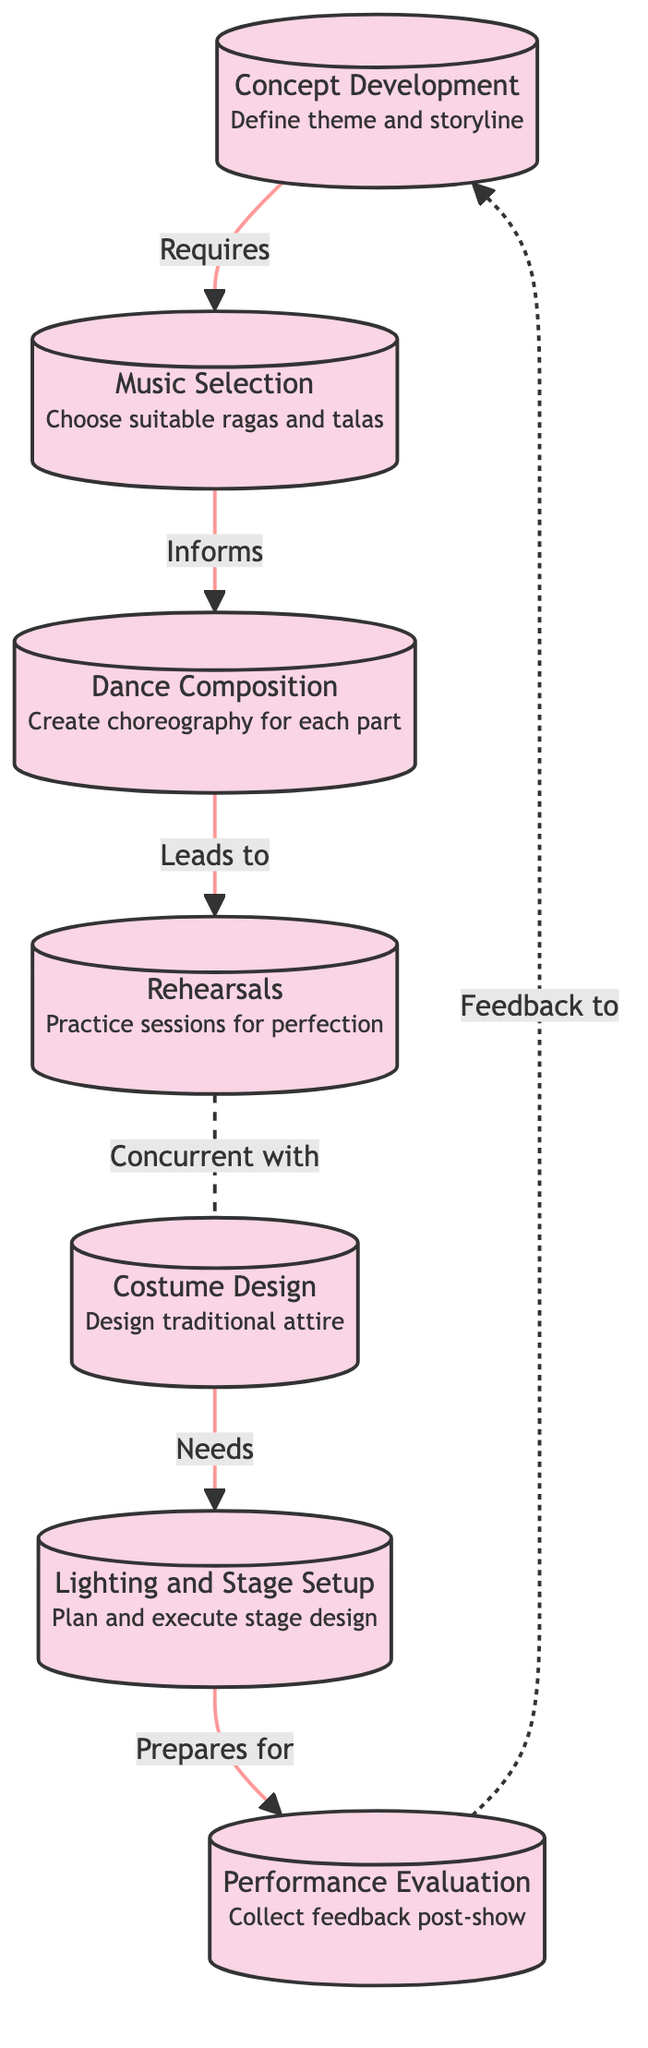What is the first step in the choreography process? The first step according to the diagram is "Concept Development," which defines the theme and storyline for the dance performance.
Answer: Concept Development How many main steps are there in the choreography process? The diagram shows a total of seven main steps in the choreography process for a traditional Indian dance performance.
Answer: Seven What node follows "Music Selection"? The node that follows "Music Selection" is "Dance Composition," which creates choreography for each part of the performance.
Answer: Dance Composition What does "Rehearsals" occur concurrently with? "Rehearsals" occur concurrently with "Costume Design," indicating that both processes are happening at the same time as part of preparing for the performance.
Answer: Costume Design Which step informs "Dance Composition"? "Music Selection" informs "Dance Composition" by providing the suitable ragas and talas needed to create the choreography for each part.
Answer: Music Selection What action does "Lighting and Stage Setup" prepare for? "Lighting and Stage Setup" prepares for "Performance Evaluation," indicating that effective stage design is crucial for assessing the performance after the show.
Answer: Performance Evaluation How does the feedback loop operate in this process? The feedback loop from "Performance Evaluation" back to "Concept Development" indicates that feedback collected after the performance can inform future concept development, creating an iterative process.
Answer: Feedback to Concept Development What is the relationship between "Costume Design" and "Lighting and Stage Setup"? "Costume Design" is a requirement for "Lighting and Stage Setup," indicating that the design of costumes needs to be completed in order to effectively plan and execute stage lighting.
Answer: Needs What type of relationship does the line between "Rehearsals" and "Costume Design" represent? The line between "Rehearsals" and "Costume Design" represents a concurrent relationship, meaning that both activities are conducted simultaneously in the preparation process.
Answer: Concurrent relationship 